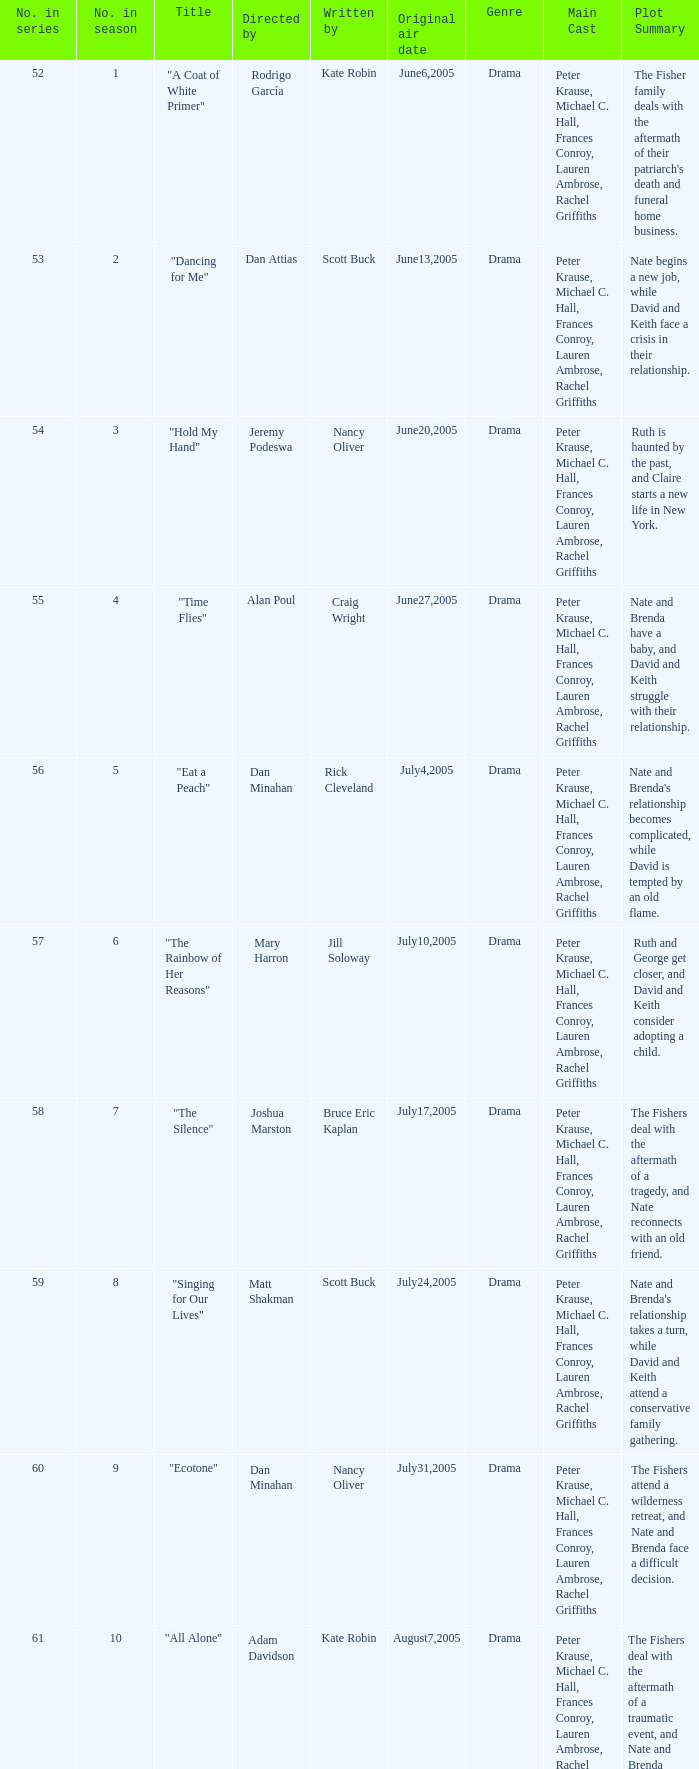What was the name of the episode that was directed by Mary Harron? "The Rainbow of Her Reasons". Could you help me parse every detail presented in this table? {'header': ['No. in series', 'No. in season', 'Title', 'Directed by', 'Written by', 'Original air date', 'Genre', 'Main Cast', 'Plot Summary '], 'rows': [['52', '1', '"A Coat of White Primer"', 'Rodrigo García', 'Kate Robin', 'June6,2005', 'Drama', 'Peter Krause, Michael C. Hall, Frances Conroy, Lauren Ambrose, Rachel Griffiths', "The Fisher family deals with the aftermath of their patriarch's death and funeral home business. "], ['53', '2', '"Dancing for Me"', 'Dan Attias', 'Scott Buck', 'June13,2005', 'Drama', 'Peter Krause, Michael C. Hall, Frances Conroy, Lauren Ambrose, Rachel Griffiths', 'Nate begins a new job, while David and Keith face a crisis in their relationship. '], ['54', '3', '"Hold My Hand"', 'Jeremy Podeswa', 'Nancy Oliver', 'June20,2005', 'Drama', 'Peter Krause, Michael C. Hall, Frances Conroy, Lauren Ambrose, Rachel Griffiths', 'Ruth is haunted by the past, and Claire starts a new life in New York. '], ['55', '4', '"Time Flies"', 'Alan Poul', 'Craig Wright', 'June27,2005', 'Drama', 'Peter Krause, Michael C. Hall, Frances Conroy, Lauren Ambrose, Rachel Griffiths', 'Nate and Brenda have a baby, and David and Keith struggle with their relationship. '], ['56', '5', '"Eat a Peach"', 'Dan Minahan', 'Rick Cleveland', 'July4,2005', 'Drama', 'Peter Krause, Michael C. Hall, Frances Conroy, Lauren Ambrose, Rachel Griffiths', "Nate and Brenda's relationship becomes complicated, while David is tempted by an old flame. "], ['57', '6', '"The Rainbow of Her Reasons"', 'Mary Harron', 'Jill Soloway', 'July10,2005', 'Drama', 'Peter Krause, Michael C. Hall, Frances Conroy, Lauren Ambrose, Rachel Griffiths', 'Ruth and George get closer, and David and Keith consider adopting a child. '], ['58', '7', '"The Silence"', 'Joshua Marston', 'Bruce Eric Kaplan', 'July17,2005', 'Drama', 'Peter Krause, Michael C. Hall, Frances Conroy, Lauren Ambrose, Rachel Griffiths', 'The Fishers deal with the aftermath of a tragedy, and Nate reconnects with an old friend. '], ['59', '8', '"Singing for Our Lives"', 'Matt Shakman', 'Scott Buck', 'July24,2005', 'Drama', 'Peter Krause, Michael C. Hall, Frances Conroy, Lauren Ambrose, Rachel Griffiths', "Nate and Brenda's relationship takes a turn, while David and Keith attend a conservative family gathering. "], ['60', '9', '"Ecotone"', 'Dan Minahan', 'Nancy Oliver', 'July31,2005', 'Drama', 'Peter Krause, Michael C. Hall, Frances Conroy, Lauren Ambrose, Rachel Griffiths', 'The Fishers attend a wilderness retreat, and Nate and Brenda face a difficult decision. '], ['61', '10', '"All Alone"', 'Adam Davidson', 'Kate Robin', 'August7,2005', 'Drama', 'Peter Krause, Michael C. Hall, Frances Conroy, Lauren Ambrose, Rachel Griffiths', 'The Fishers deal with the aftermath of a traumatic event, and Nate and Brenda make a life-changing decision. '], ['62', '11', '"Static"', 'Michael Cuesta', 'Craig Wright', 'August14,2005', 'Drama', 'Peter Krause, Michael C. Hall, Frances Conroy, Lauren Ambrose, Rachel Griffiths', 'The Fishers face a crisis in the funeral home business, while Ruth considers her future.']]} 